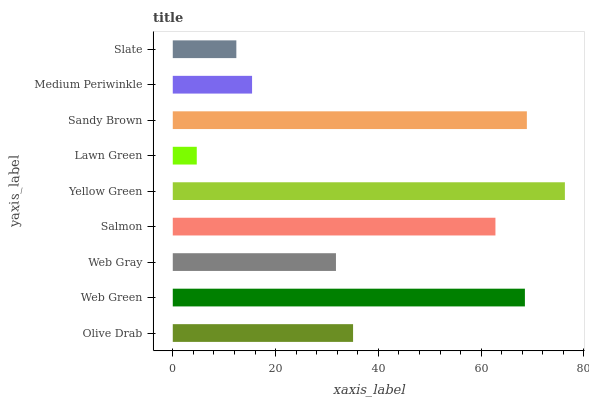Is Lawn Green the minimum?
Answer yes or no. Yes. Is Yellow Green the maximum?
Answer yes or no. Yes. Is Web Green the minimum?
Answer yes or no. No. Is Web Green the maximum?
Answer yes or no. No. Is Web Green greater than Olive Drab?
Answer yes or no. Yes. Is Olive Drab less than Web Green?
Answer yes or no. Yes. Is Olive Drab greater than Web Green?
Answer yes or no. No. Is Web Green less than Olive Drab?
Answer yes or no. No. Is Olive Drab the high median?
Answer yes or no. Yes. Is Olive Drab the low median?
Answer yes or no. Yes. Is Lawn Green the high median?
Answer yes or no. No. Is Web Green the low median?
Answer yes or no. No. 